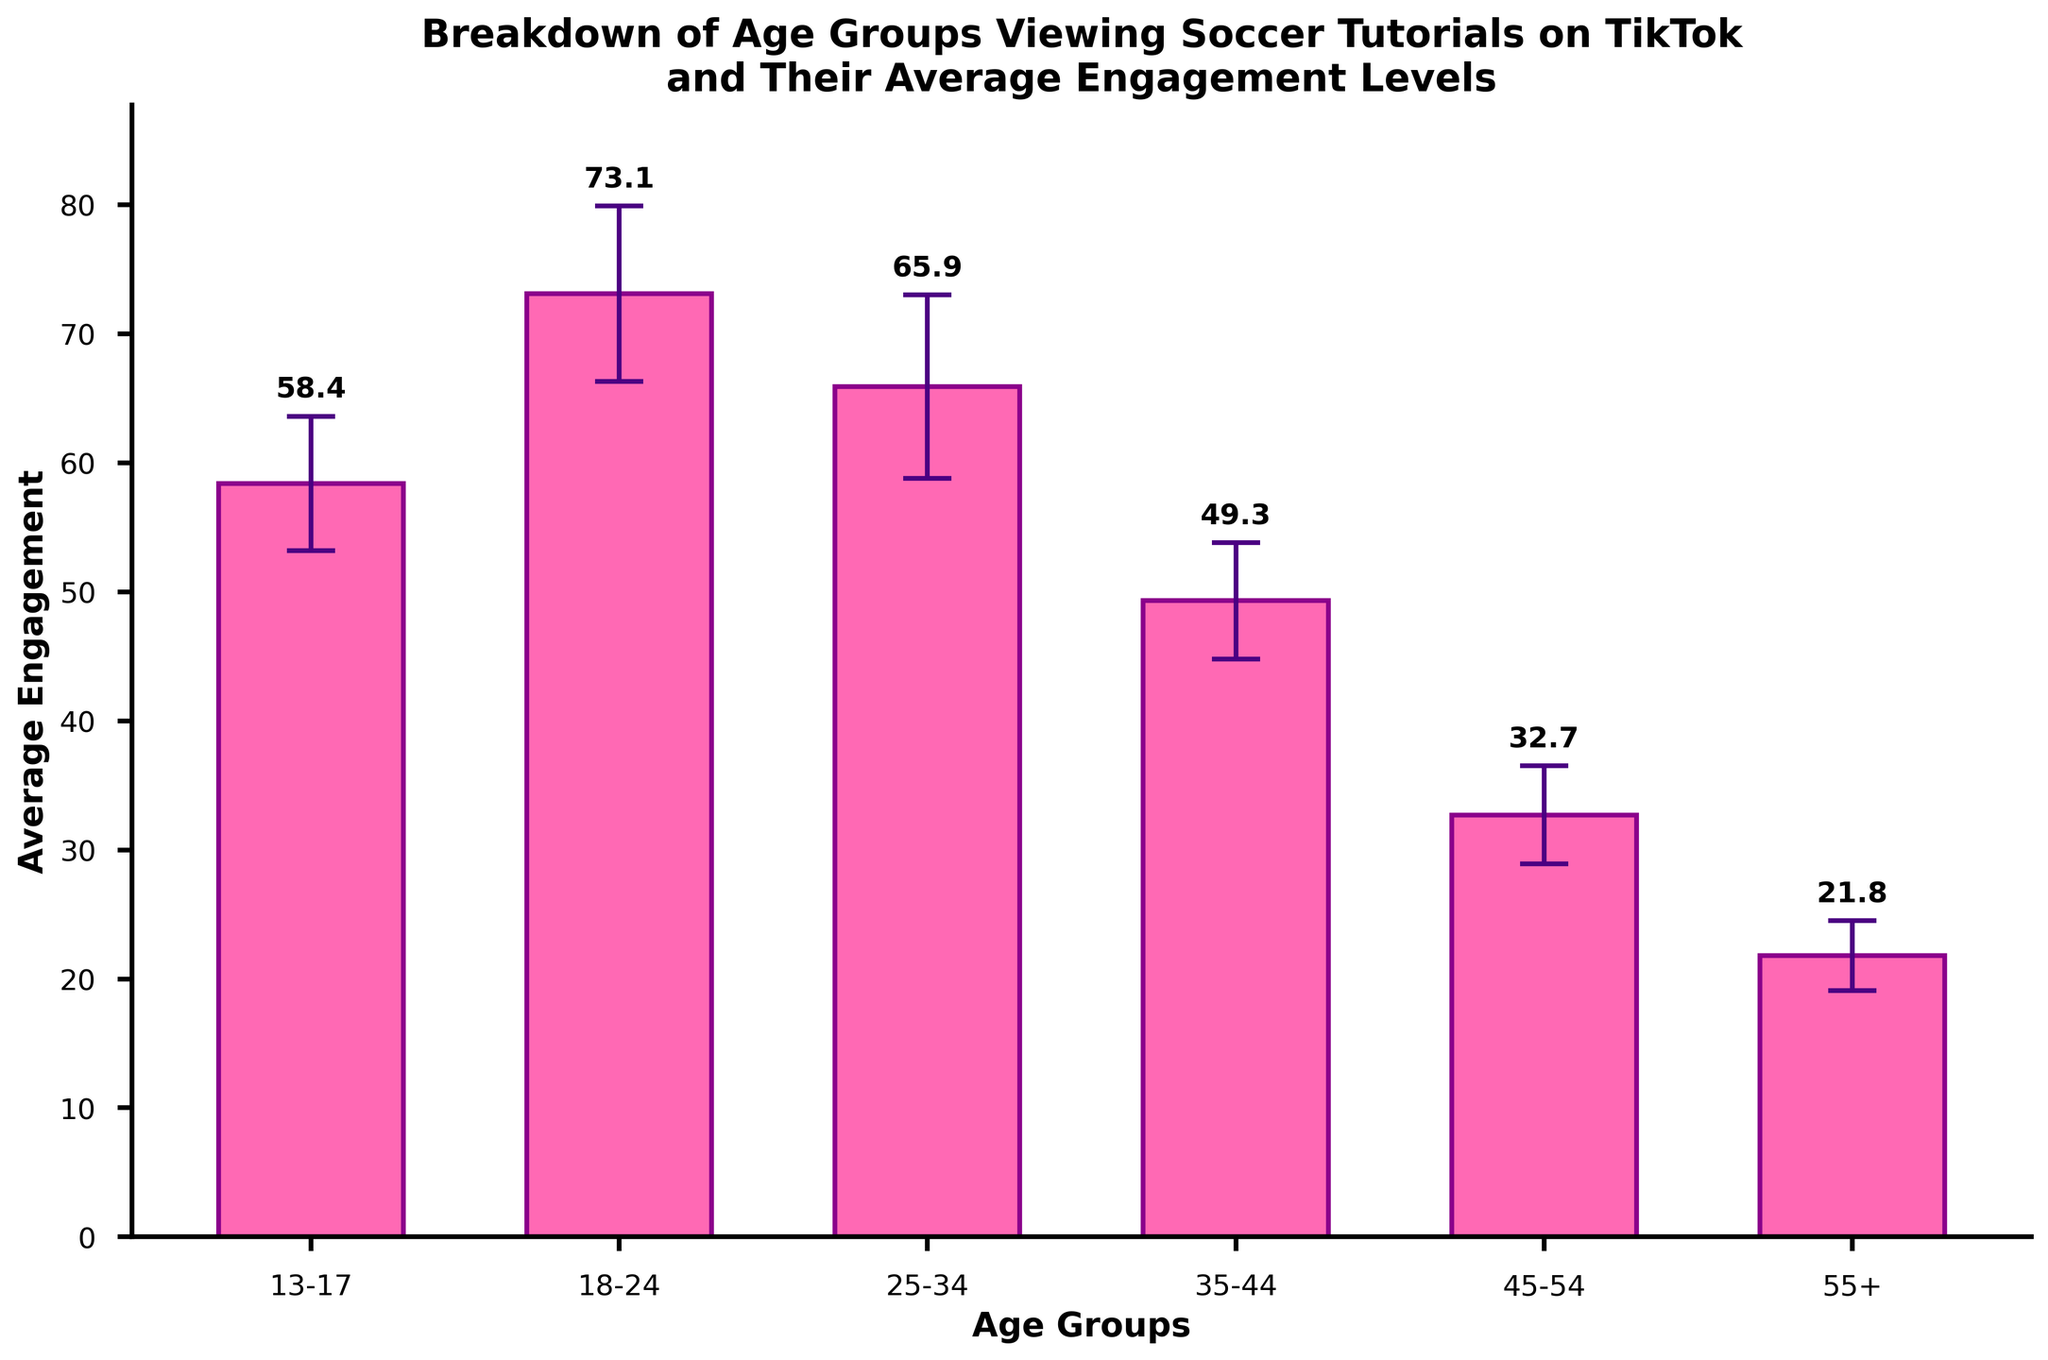What is the average engagement level for the age group 18-24? The bar for the 18-24 age group reaches a height that corresponds to their average engagement level. This value is shown in the label above the bar.
Answer: 73.1 Which age group has the lowest average engagement level? By observing the heights of the bars, the age group with the smallest bar height corresponds to the lowest average engagement level.
Answer: 55+ What is the difference in average engagement levels between the 18-24 and 35-44 age groups? Subtract the average engagement level of the 35-44 age group from that of the 18-24 age group: 73.1 - 49.3 = 23.8.
Answer: 23.8 Which age group has the most variability in engagement levels? The age group with the largest error bar (standard deviation) shows the most variability. The heights of the error bars are visually compared.
Answer: 25-34 How many age groups have average engagement levels above 50? Count the number of bars whose heights exceed the level indicated by 50 on the y-axis.
Answer: 3 What is the sum of average engagement levels for the age groups 13-17 and 55+? Add the average engagement levels of the 13-17 and 55+ age groups: 58.4 + 21.8 = 80.2.
Answer: 80.2 How does the average engagement level of the age group 25-34 compare to that of the age group 18-24? The average engagement level of the 25-34 age group (65.9) is compared with that of the 18-24 age group (73.1). The 25-34 group has a lower average engagement level.
Answer: less What is the overall trend in average engagement levels as the age groups increase? Observe the pattern formed by the heights of the bars from the youngest to the oldest age groups: engagement levels generally decrease as age increases.
Answer: decrease Which two consecutive age groups have the smallest difference in their average engagement levels? Compute the difference in average engagement levels for all consecutive age groups and find the smallest difference: 
13-17 and 18-24: 73.1 - 58.4 = 14.7 
18-24 and 25-34: 73.1 - 65.9 = 7.2 
25-34 and 35-44: 65.9 - 49.3 = 16.6 
35-44 and 45-54: 49.3 - 32.7 = 16.6 
45-54 and 55+: 32.7 - 21.8 = 10.9 
The smallest difference is 7.2 between age groups 18-24 and 25-34.
Answer: 18-24 and 25-34 